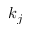Convert formula to latex. <formula><loc_0><loc_0><loc_500><loc_500>k _ { j }</formula> 